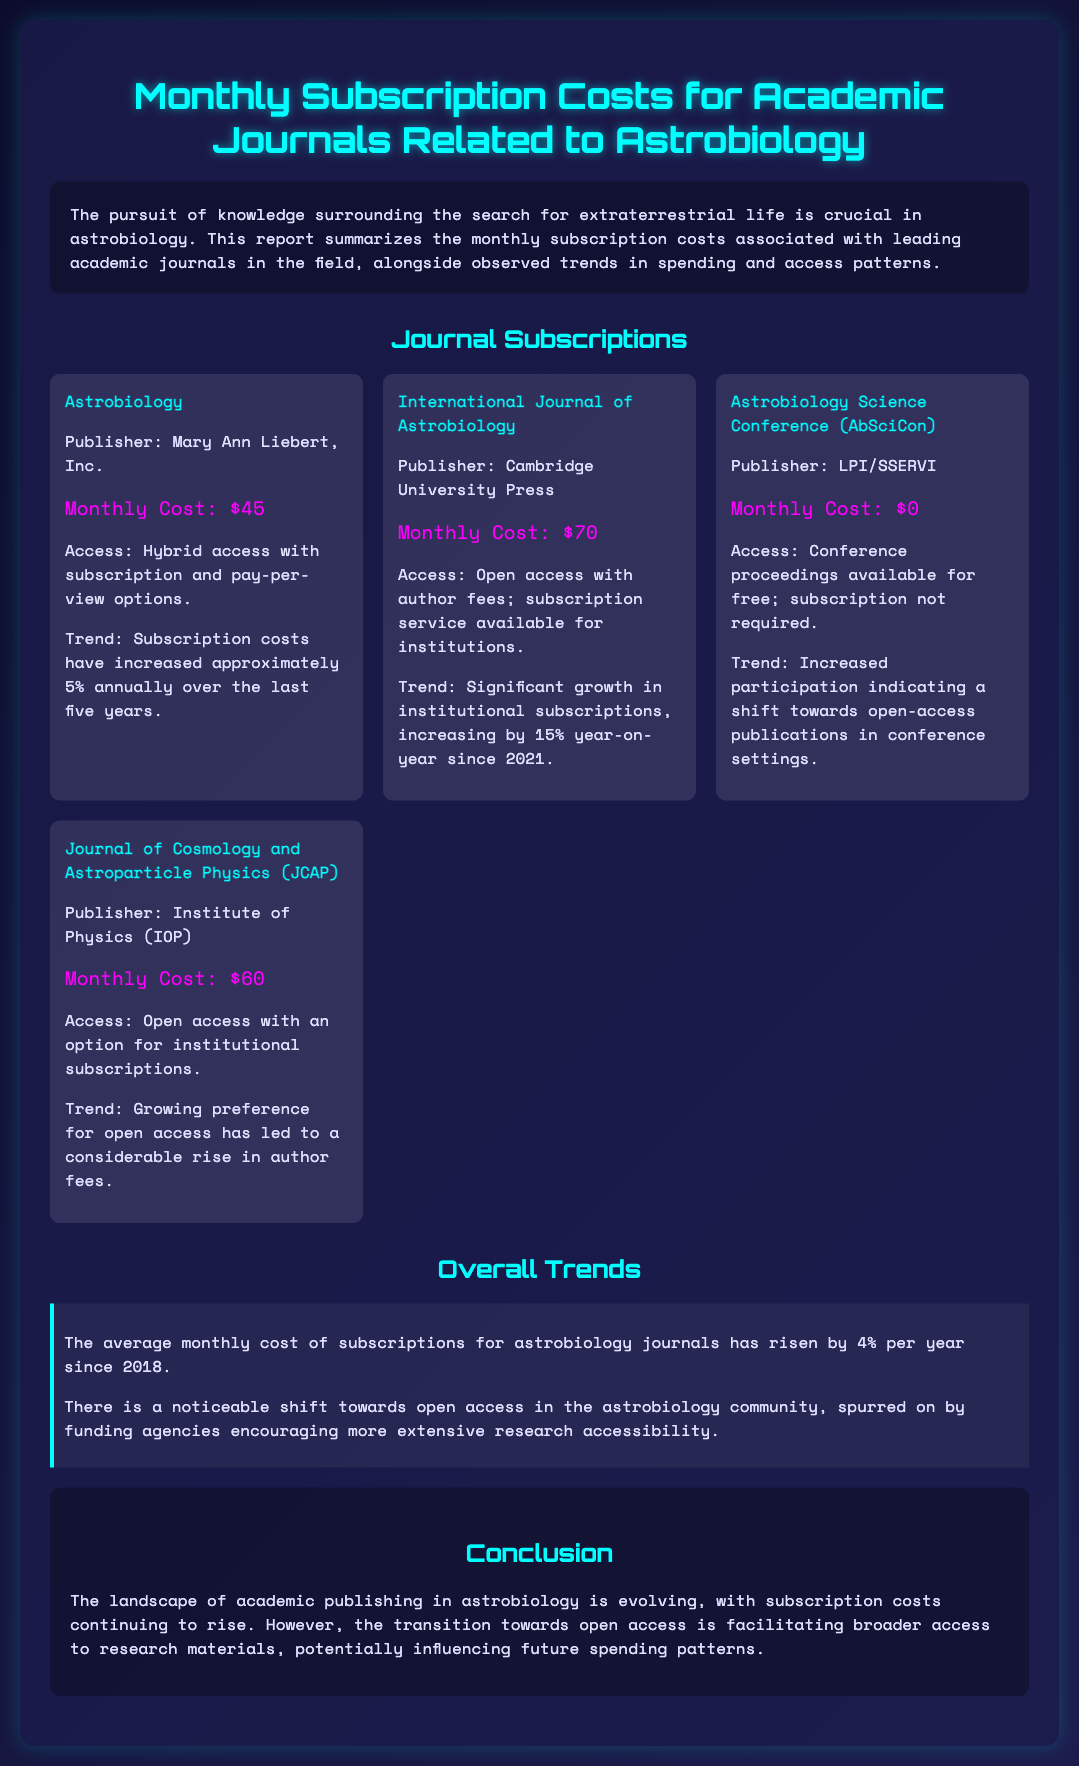What is the monthly cost for the "Astrobiology" journal? The monthly cost is specifically stated in the document as $45.
Answer: $45 What trend is associated with the "International Journal of Astrobiology"? The document mentions a significant growth in institutional subscriptions, increasing by 15% year-on-year since 2021.
Answer: 15% Which publisher produces "Astrobiology Science Conference (AbSciCon)"? The publisher of this journal is specified as LPI/SSERVI in the document.
Answer: LPI/SSERVI What is the average annual increase in monthly subscription costs for astrobiology journals? The document provides the average increase as 4% per year since 2018.
Answer: 4% What type of access is associated with "Journal of Cosmology and Astroparticle Physics (JCAP)"? The access type mentioned in connection with JCAP is open access with an option for institutional subscriptions.
Answer: Open access What is the notable shift observed in the astrobiology community? The document highlights a noticeable shift towards open access in the community.
Answer: Open access 